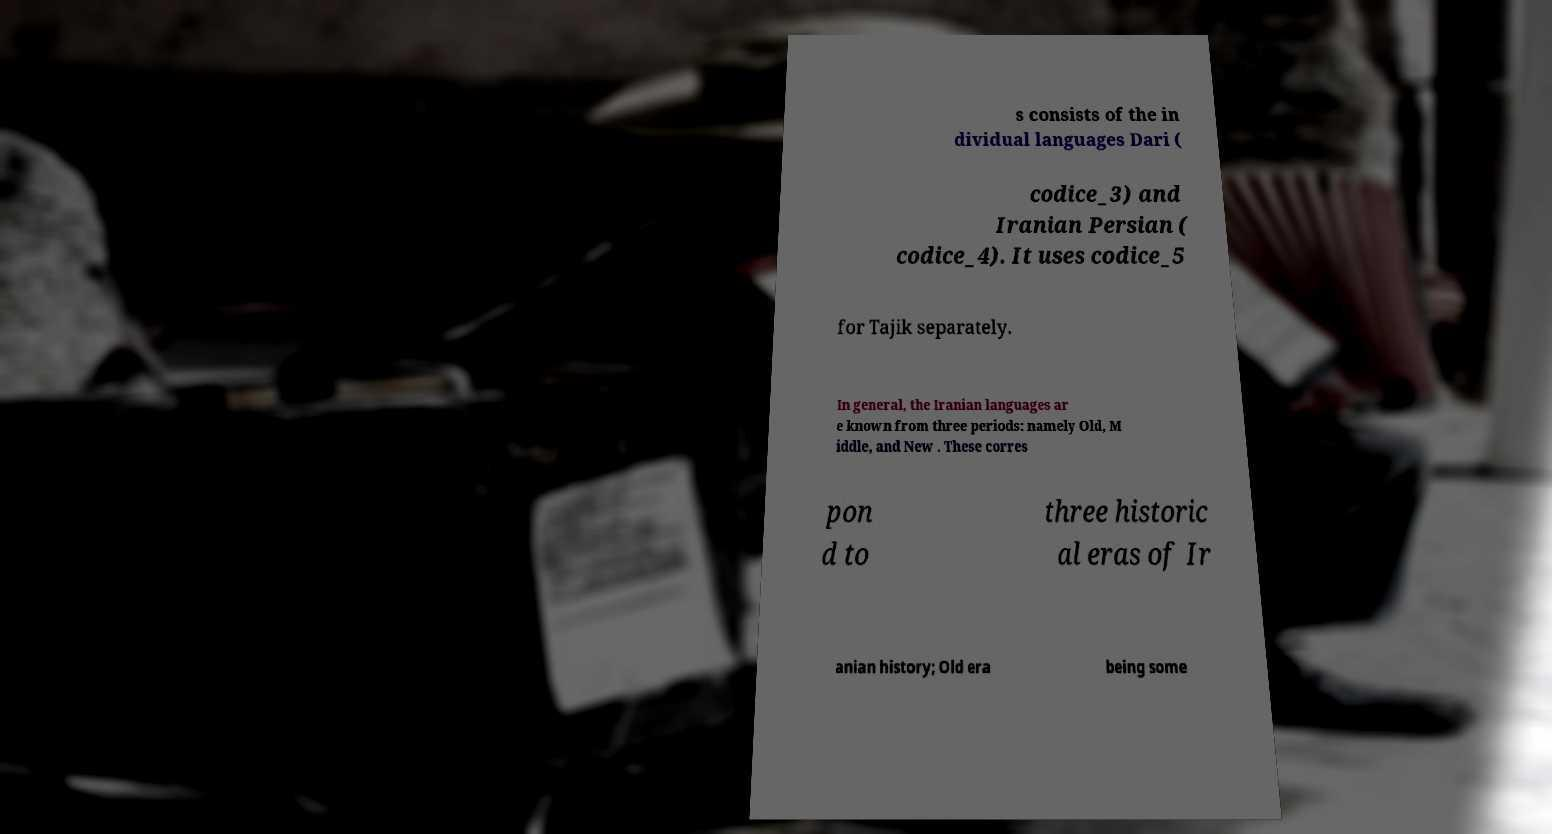Can you read and provide the text displayed in the image?This photo seems to have some interesting text. Can you extract and type it out for me? s consists of the in dividual languages Dari ( codice_3) and Iranian Persian ( codice_4). It uses codice_5 for Tajik separately. In general, the Iranian languages ar e known from three periods: namely Old, M iddle, and New . These corres pon d to three historic al eras of Ir anian history; Old era being some 